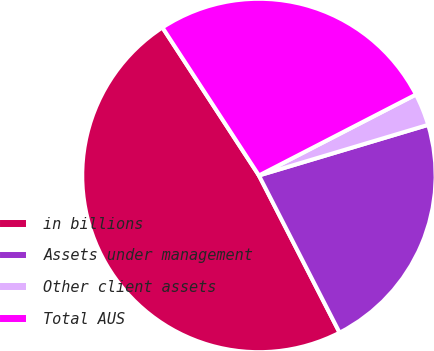Convert chart. <chart><loc_0><loc_0><loc_500><loc_500><pie_chart><fcel>in billions<fcel>Assets under management<fcel>Other client assets<fcel>Total AUS<nl><fcel>48.35%<fcel>22.08%<fcel>2.95%<fcel>26.62%<nl></chart> 